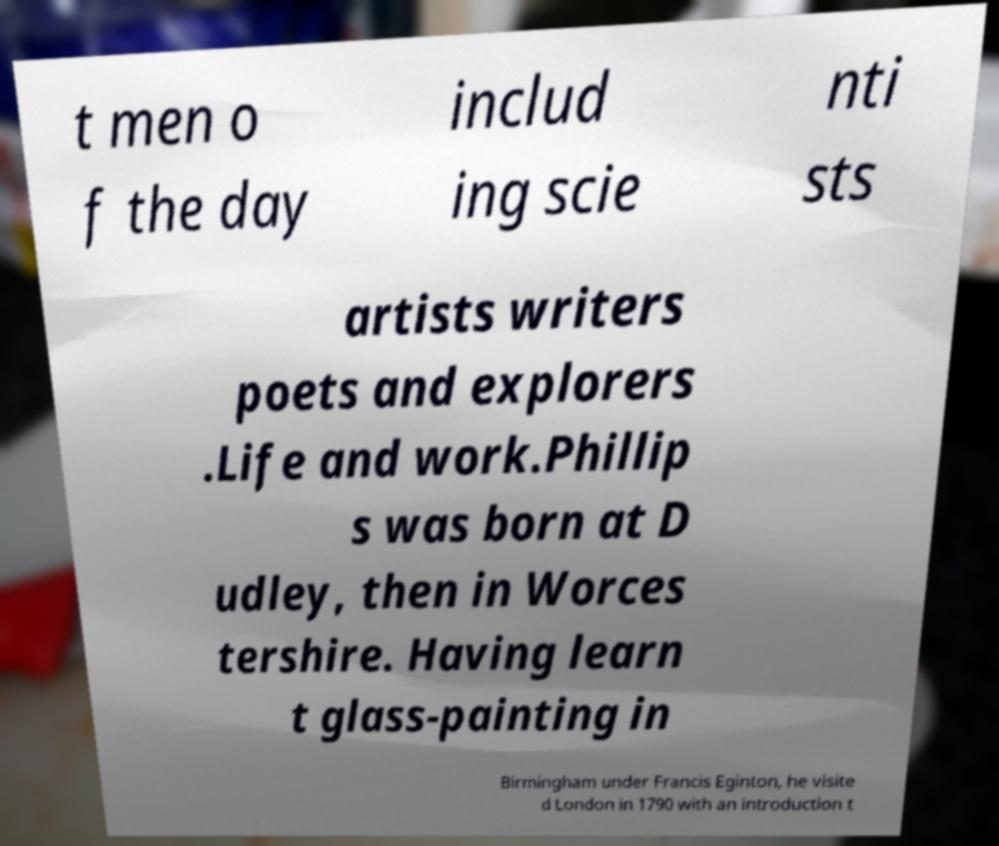Please read and relay the text visible in this image. What does it say? t men o f the day includ ing scie nti sts artists writers poets and explorers .Life and work.Phillip s was born at D udley, then in Worces tershire. Having learn t glass-painting in Birmingham under Francis Eginton, he visite d London in 1790 with an introduction t 